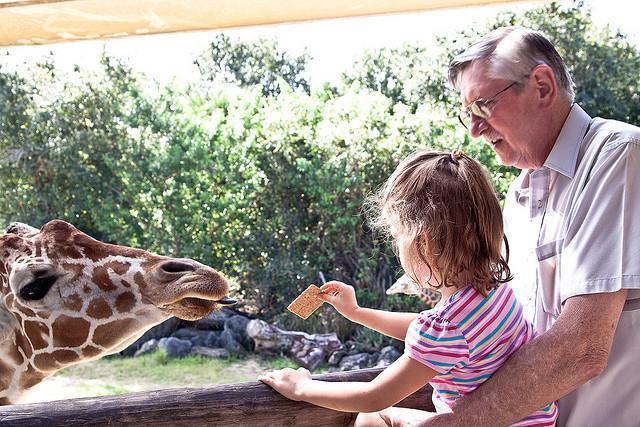How many people are in the picture?
Give a very brief answer. 2. 